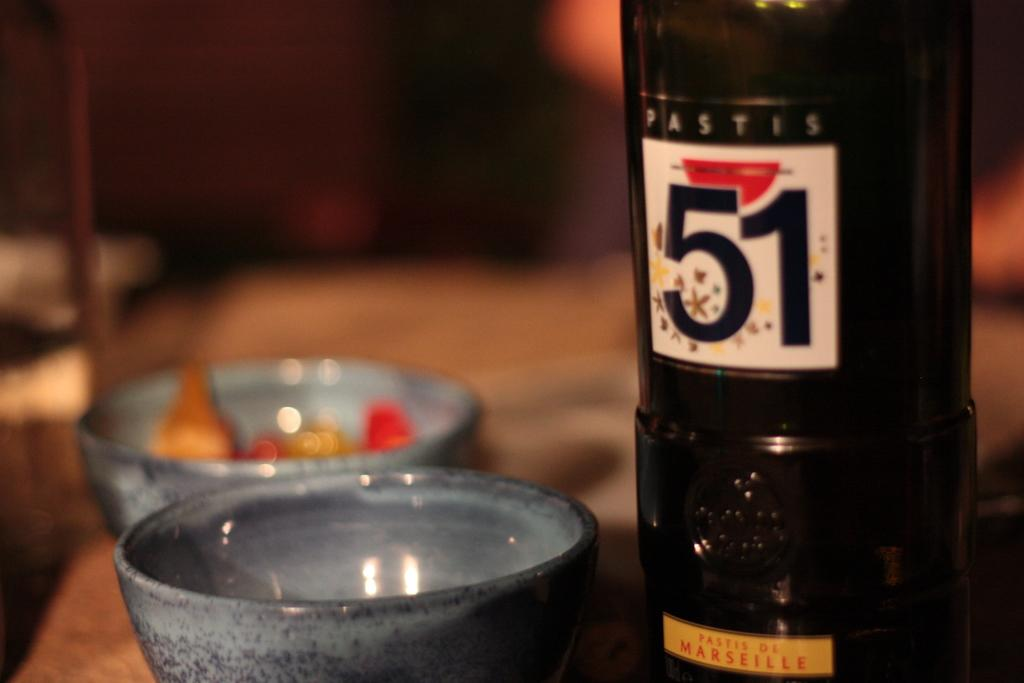Provide a one-sentence caption for the provided image. A black bottle of Pastis 51 from France next to a grey bowl. 